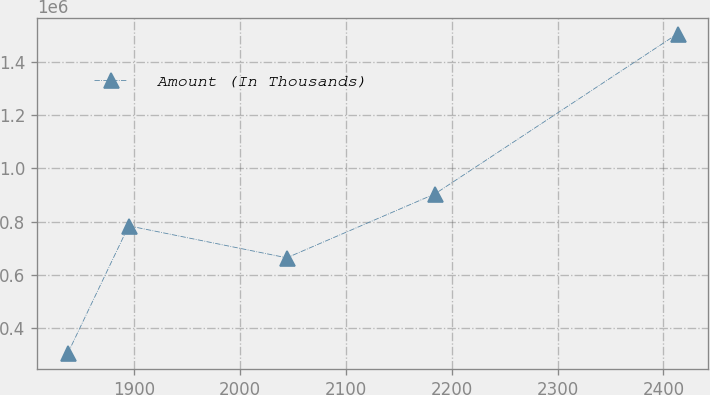Convert chart to OTSL. <chart><loc_0><loc_0><loc_500><loc_500><line_chart><ecel><fcel>Amount (In Thousands)<nl><fcel>1837.72<fcel>305511<nl><fcel>1895.29<fcel>784329<nl><fcel>2044.48<fcel>664355<nl><fcel>2184.39<fcel>904303<nl><fcel>2413.4<fcel>1.50525e+06<nl></chart> 